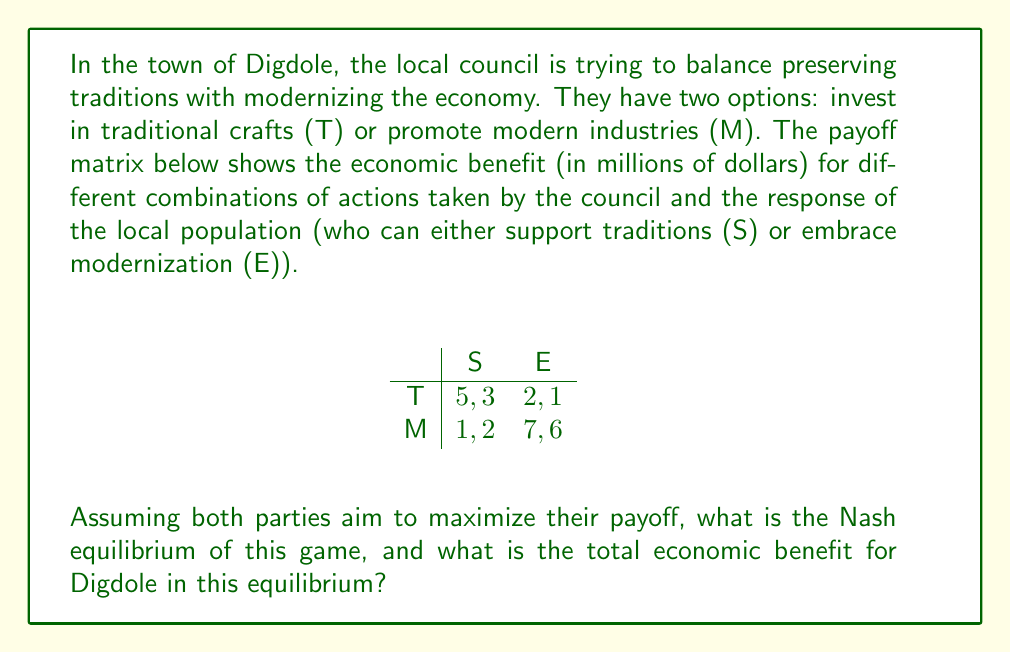Can you answer this question? To solve this problem, we need to find the Nash equilibrium of the game. A Nash equilibrium is a set of strategies where neither player can unilaterally improve their payoff by changing their strategy.

Let's analyze the strategies:

1. If the population chooses S:
   - Council's best response is T (payoff 5 > 1)

2. If the population chooses E:
   - Council's best response is M (payoff 7 > 2)

3. If the council chooses T:
   - Population's best response is S (payoff 3 > 1)

4. If the council chooses M:
   - Population's best response is E (payoff 6 > 2)

From this analysis, we can see that there are two pure strategy Nash equilibria:
1. (T, S) with payoffs (5, 3)
2. (M, E) with payoffs (7, 6)

The (M, E) equilibrium has higher payoffs for both players, so it's the Pareto-optimal Nash equilibrium. This means that the council will choose to promote modern industries (M), and the population will embrace modernization (E).

The total economic benefit for Digdole in this equilibrium is the sum of the payoffs:

$$ 7 + 6 = 13 \text{ million dollars} $$
Answer: The Nash equilibrium is (M, E), and the total economic benefit for Digdole in this equilibrium is $13 million. 